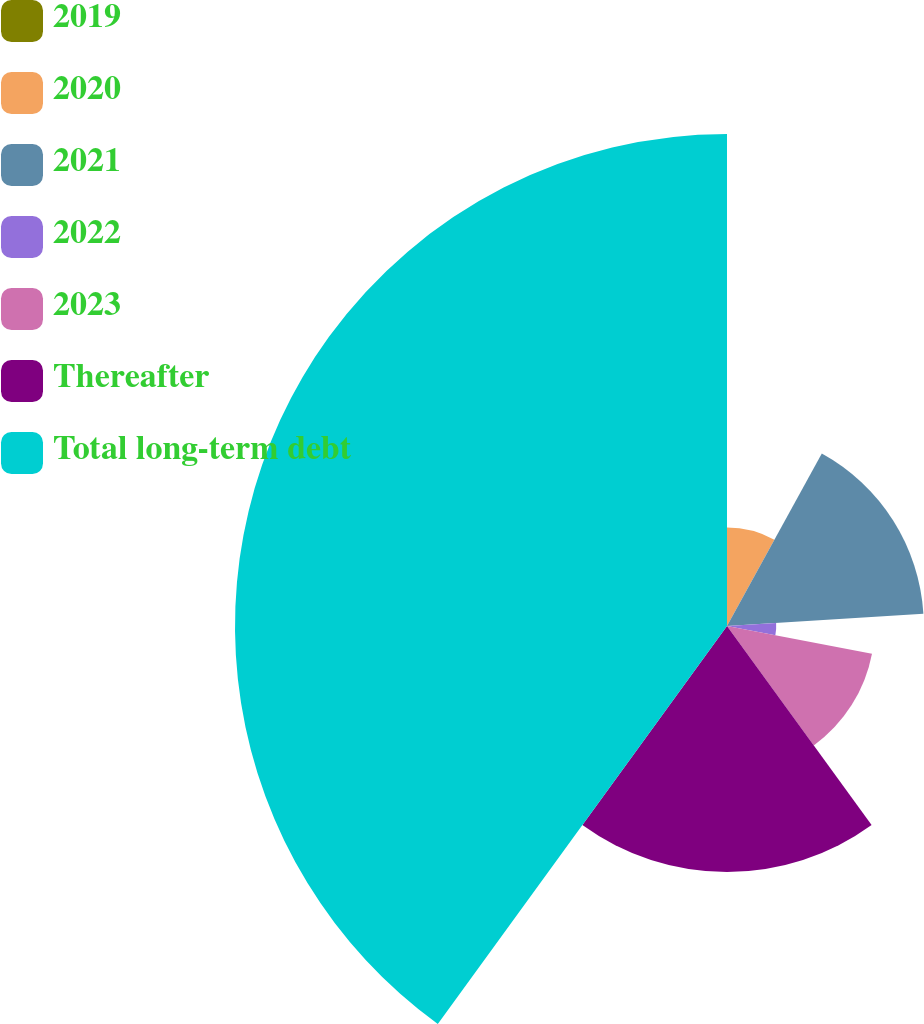Convert chart. <chart><loc_0><loc_0><loc_500><loc_500><pie_chart><fcel>2019<fcel>2020<fcel>2021<fcel>2022<fcel>2023<fcel>Thereafter<fcel>Total long-term debt<nl><fcel>0.0%<fcel>8.0%<fcel>16.0%<fcel>4.0%<fcel>12.0%<fcel>20.0%<fcel>40.0%<nl></chart> 